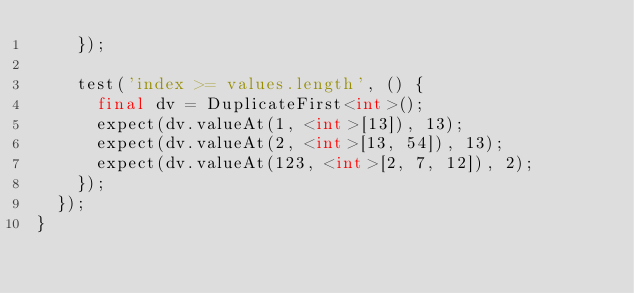Convert code to text. <code><loc_0><loc_0><loc_500><loc_500><_Dart_>    });

    test('index >= values.length', () {
      final dv = DuplicateFirst<int>();
      expect(dv.valueAt(1, <int>[13]), 13);
      expect(dv.valueAt(2, <int>[13, 54]), 13);
      expect(dv.valueAt(123, <int>[2, 7, 12]), 2);
    });
  });
}
</code> 